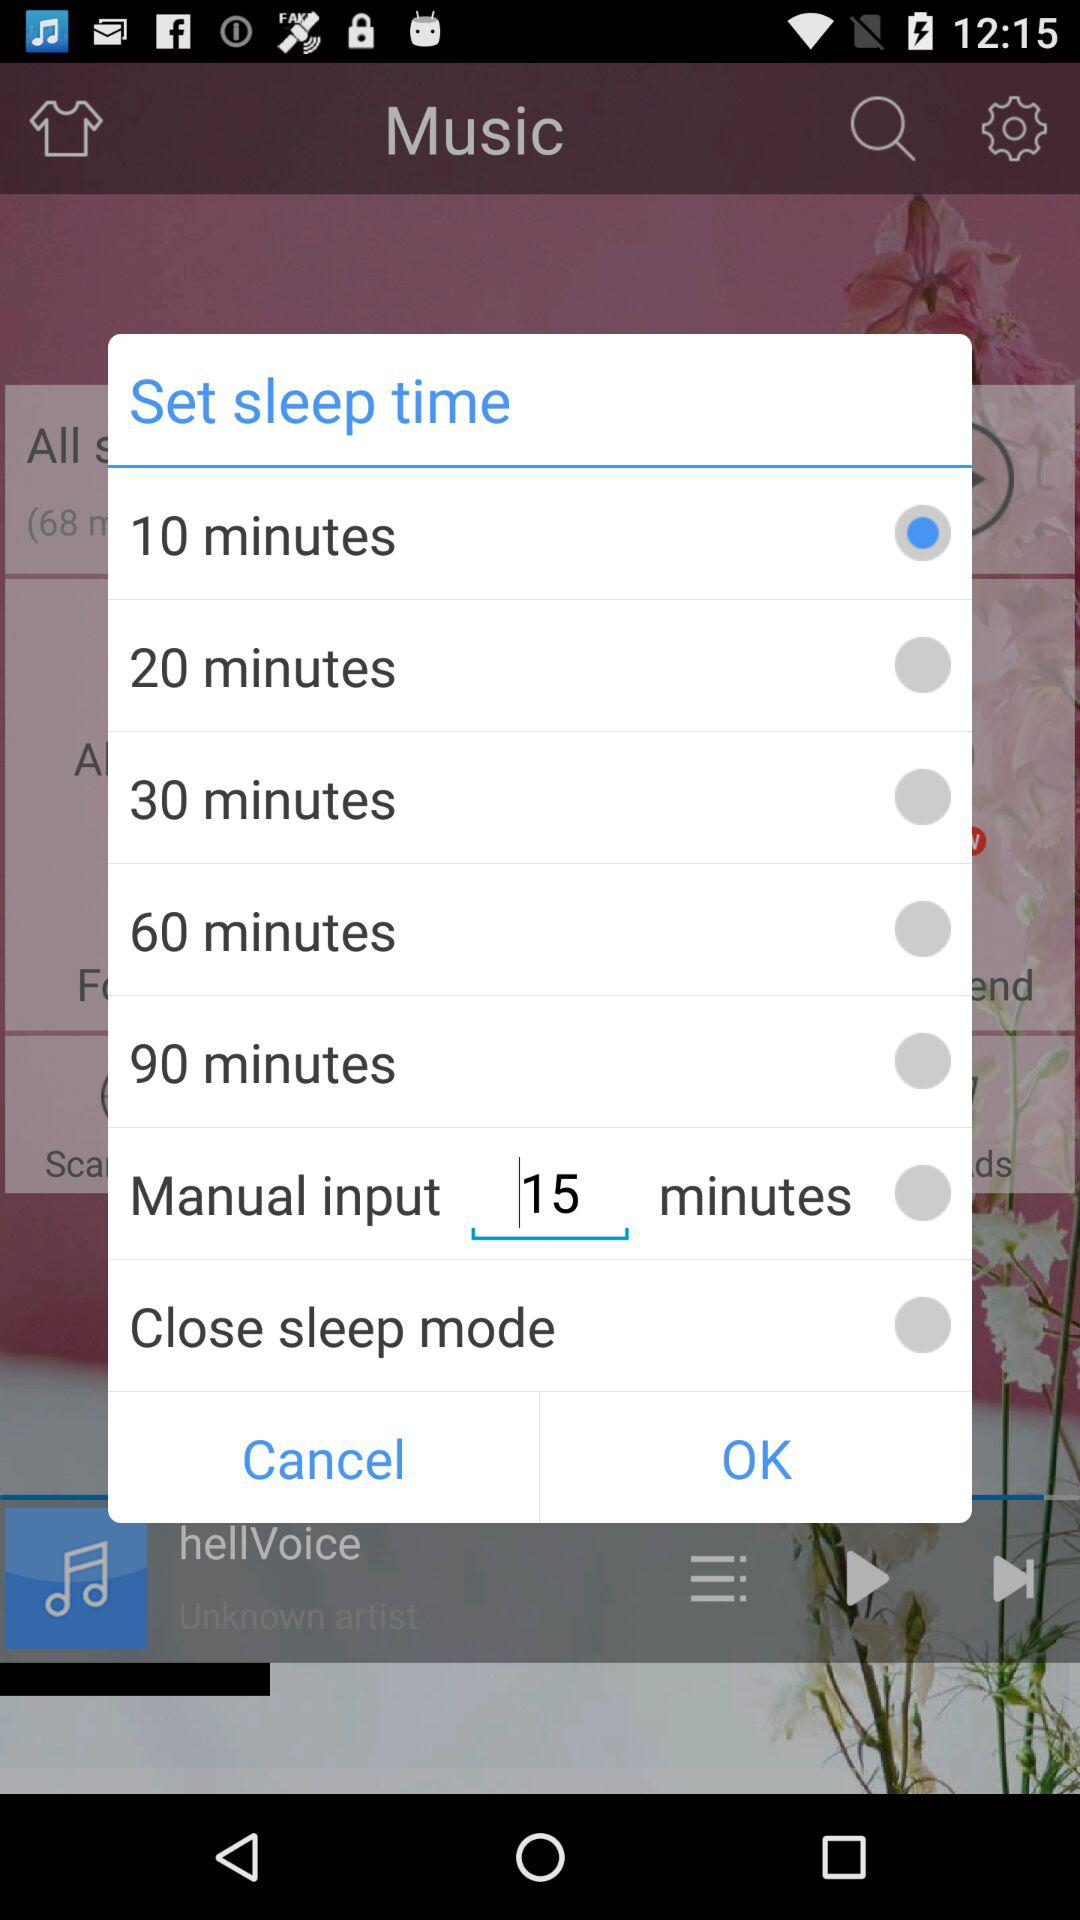What is the selected option? The selected option is "10 minutes". 